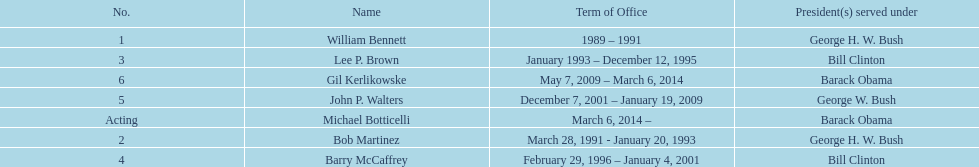How long did lee p. brown serve for? 2 years. 